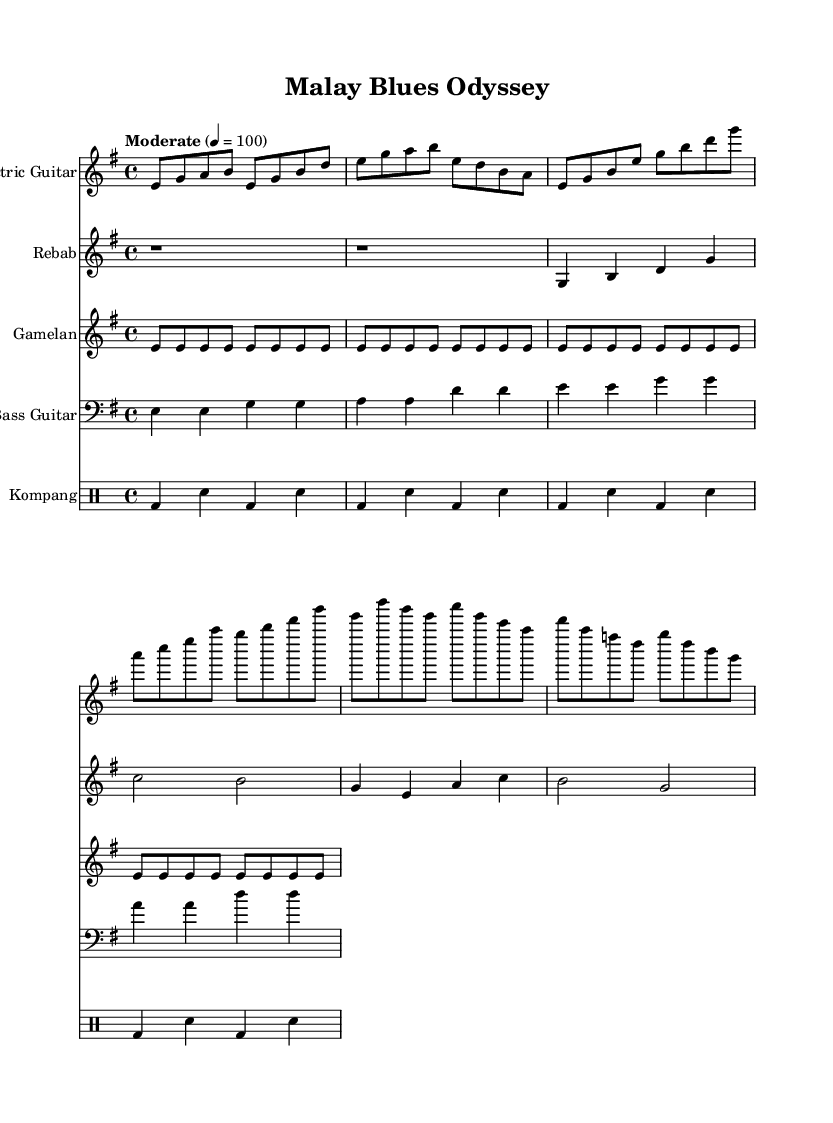What is the key signature of this music? The key signature indicated in the music is indicated by the key signature symbol that appears at the beginning of the staff. In this case, it's E minor, which has one sharp (F#).
Answer: E minor What is the time signature of this music? The time signature is represented at the beginning of the music fragment, shown as 4/4, which indicates there are four beats in a measure and the quarter note gets the beat.
Answer: 4/4 What is the tempo marking for this piece? The tempo marking appears at the beginning of the score and indicates the speed at which the piece should be played. In this case, it states "Moderate" with a metronomic marking of 100 beats per minute.
Answer: Moderate 4 = 100 How many measures are in the electric guitar section? By counting the number of vertical lines that separate the notes in the electric guitar section, we can determine the number of measures. In this case, there are 8 measures shown for the electric guitar.
Answer: 8 What instrument accompanies the rebab in the score? The rebab is accompanied by the electric guitar and gamelan in the score. They all appear in their respective staves that are aligned vertically, indicating simultaneous playing.
Answer: Electric guitar and gamelan What rhythmic pattern does the kompang play? The rhythmic pattern played by the kompang is found in the drum staff, displaying the pattern comprising a bass drum hit followed by a snare hit. Upon observing the score, it shows a repeated pattern of "bd sn" (bass drum and snare).
Answer: bd sn How does the bass guitar's rhythm compare to the electric guitar's rhythm? The bass guitar's rhythm is simpler and supports the harmonic foundation, while the electric guitar has a more melodically complex rhythm. The bass follows a repetitive pattern, while the guitar features more variations and movement.
Answer: Simpler and supportive 